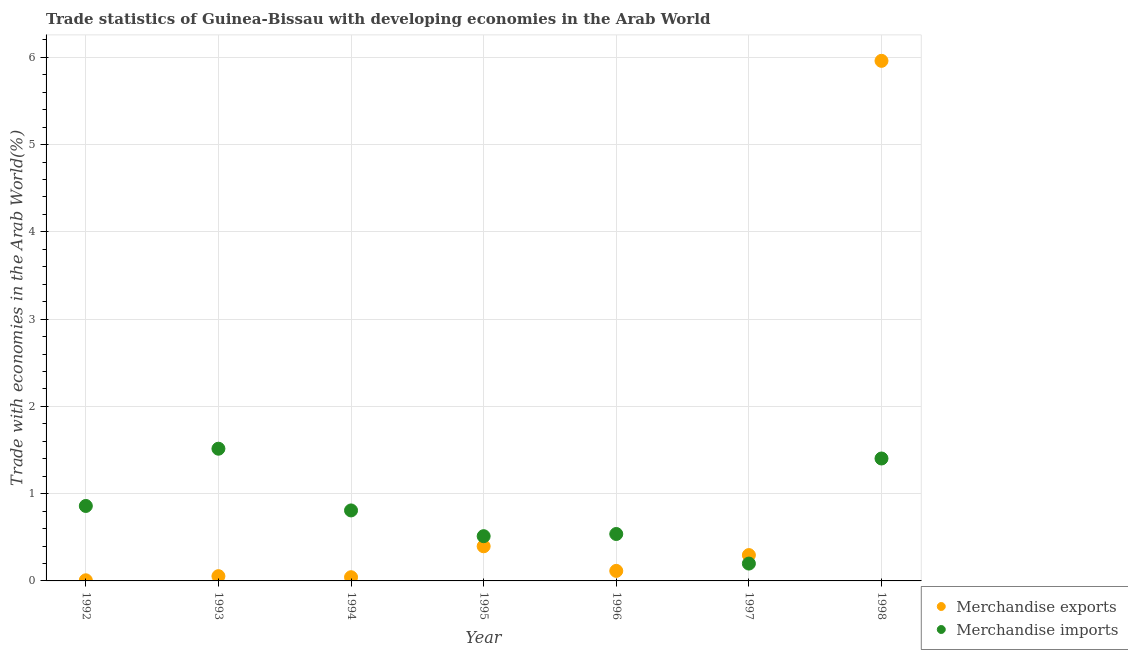What is the merchandise exports in 1994?
Your response must be concise. 0.04. Across all years, what is the maximum merchandise imports?
Give a very brief answer. 1.52. Across all years, what is the minimum merchandise imports?
Ensure brevity in your answer.  0.2. In which year was the merchandise exports maximum?
Your answer should be compact. 1998. What is the total merchandise imports in the graph?
Make the answer very short. 5.83. What is the difference between the merchandise exports in 1994 and that in 1997?
Your answer should be compact. -0.25. What is the difference between the merchandise exports in 1997 and the merchandise imports in 1998?
Give a very brief answer. -1.11. What is the average merchandise exports per year?
Make the answer very short. 0.98. In the year 1997, what is the difference between the merchandise exports and merchandise imports?
Your answer should be compact. 0.1. What is the ratio of the merchandise imports in 1992 to that in 1994?
Provide a short and direct response. 1.06. What is the difference between the highest and the second highest merchandise imports?
Keep it short and to the point. 0.11. What is the difference between the highest and the lowest merchandise imports?
Provide a succinct answer. 1.32. In how many years, is the merchandise exports greater than the average merchandise exports taken over all years?
Your answer should be very brief. 1. How many dotlines are there?
Provide a short and direct response. 2. Does the graph contain grids?
Offer a terse response. Yes. How many legend labels are there?
Offer a very short reply. 2. What is the title of the graph?
Give a very brief answer. Trade statistics of Guinea-Bissau with developing economies in the Arab World. Does "Mobile cellular" appear as one of the legend labels in the graph?
Provide a succinct answer. No. What is the label or title of the X-axis?
Your response must be concise. Year. What is the label or title of the Y-axis?
Provide a short and direct response. Trade with economies in the Arab World(%). What is the Trade with economies in the Arab World(%) in Merchandise exports in 1992?
Give a very brief answer. 0.01. What is the Trade with economies in the Arab World(%) in Merchandise imports in 1992?
Provide a short and direct response. 0.86. What is the Trade with economies in the Arab World(%) in Merchandise exports in 1993?
Ensure brevity in your answer.  0.05. What is the Trade with economies in the Arab World(%) of Merchandise imports in 1993?
Provide a succinct answer. 1.52. What is the Trade with economies in the Arab World(%) in Merchandise exports in 1994?
Your response must be concise. 0.04. What is the Trade with economies in the Arab World(%) of Merchandise imports in 1994?
Give a very brief answer. 0.81. What is the Trade with economies in the Arab World(%) of Merchandise exports in 1995?
Give a very brief answer. 0.4. What is the Trade with economies in the Arab World(%) of Merchandise imports in 1995?
Your answer should be very brief. 0.51. What is the Trade with economies in the Arab World(%) of Merchandise exports in 1996?
Make the answer very short. 0.11. What is the Trade with economies in the Arab World(%) of Merchandise imports in 1996?
Your response must be concise. 0.54. What is the Trade with economies in the Arab World(%) in Merchandise exports in 1997?
Your answer should be very brief. 0.3. What is the Trade with economies in the Arab World(%) in Merchandise imports in 1997?
Ensure brevity in your answer.  0.2. What is the Trade with economies in the Arab World(%) in Merchandise exports in 1998?
Your answer should be compact. 5.96. What is the Trade with economies in the Arab World(%) in Merchandise imports in 1998?
Offer a very short reply. 1.4. Across all years, what is the maximum Trade with economies in the Arab World(%) of Merchandise exports?
Keep it short and to the point. 5.96. Across all years, what is the maximum Trade with economies in the Arab World(%) of Merchandise imports?
Provide a short and direct response. 1.52. Across all years, what is the minimum Trade with economies in the Arab World(%) in Merchandise exports?
Your response must be concise. 0.01. Across all years, what is the minimum Trade with economies in the Arab World(%) of Merchandise imports?
Ensure brevity in your answer.  0.2. What is the total Trade with economies in the Arab World(%) of Merchandise exports in the graph?
Offer a terse response. 6.87. What is the total Trade with economies in the Arab World(%) in Merchandise imports in the graph?
Offer a very short reply. 5.83. What is the difference between the Trade with economies in the Arab World(%) in Merchandise exports in 1992 and that in 1993?
Your answer should be compact. -0.05. What is the difference between the Trade with economies in the Arab World(%) of Merchandise imports in 1992 and that in 1993?
Offer a terse response. -0.66. What is the difference between the Trade with economies in the Arab World(%) in Merchandise exports in 1992 and that in 1994?
Your response must be concise. -0.04. What is the difference between the Trade with economies in the Arab World(%) of Merchandise imports in 1992 and that in 1994?
Keep it short and to the point. 0.05. What is the difference between the Trade with economies in the Arab World(%) of Merchandise exports in 1992 and that in 1995?
Ensure brevity in your answer.  -0.39. What is the difference between the Trade with economies in the Arab World(%) of Merchandise imports in 1992 and that in 1995?
Provide a short and direct response. 0.35. What is the difference between the Trade with economies in the Arab World(%) in Merchandise exports in 1992 and that in 1996?
Your answer should be very brief. -0.11. What is the difference between the Trade with economies in the Arab World(%) in Merchandise imports in 1992 and that in 1996?
Make the answer very short. 0.32. What is the difference between the Trade with economies in the Arab World(%) in Merchandise exports in 1992 and that in 1997?
Your answer should be very brief. -0.29. What is the difference between the Trade with economies in the Arab World(%) of Merchandise imports in 1992 and that in 1997?
Ensure brevity in your answer.  0.66. What is the difference between the Trade with economies in the Arab World(%) of Merchandise exports in 1992 and that in 1998?
Offer a very short reply. -5.95. What is the difference between the Trade with economies in the Arab World(%) in Merchandise imports in 1992 and that in 1998?
Your response must be concise. -0.54. What is the difference between the Trade with economies in the Arab World(%) of Merchandise exports in 1993 and that in 1994?
Offer a very short reply. 0.01. What is the difference between the Trade with economies in the Arab World(%) in Merchandise imports in 1993 and that in 1994?
Provide a succinct answer. 0.71. What is the difference between the Trade with economies in the Arab World(%) in Merchandise exports in 1993 and that in 1995?
Your answer should be compact. -0.34. What is the difference between the Trade with economies in the Arab World(%) of Merchandise imports in 1993 and that in 1995?
Make the answer very short. 1. What is the difference between the Trade with economies in the Arab World(%) in Merchandise exports in 1993 and that in 1996?
Offer a very short reply. -0.06. What is the difference between the Trade with economies in the Arab World(%) in Merchandise imports in 1993 and that in 1996?
Your answer should be very brief. 0.98. What is the difference between the Trade with economies in the Arab World(%) in Merchandise exports in 1993 and that in 1997?
Offer a very short reply. -0.24. What is the difference between the Trade with economies in the Arab World(%) of Merchandise imports in 1993 and that in 1997?
Ensure brevity in your answer.  1.32. What is the difference between the Trade with economies in the Arab World(%) in Merchandise exports in 1993 and that in 1998?
Keep it short and to the point. -5.91. What is the difference between the Trade with economies in the Arab World(%) of Merchandise imports in 1993 and that in 1998?
Provide a succinct answer. 0.11. What is the difference between the Trade with economies in the Arab World(%) of Merchandise exports in 1994 and that in 1995?
Ensure brevity in your answer.  -0.35. What is the difference between the Trade with economies in the Arab World(%) of Merchandise imports in 1994 and that in 1995?
Give a very brief answer. 0.3. What is the difference between the Trade with economies in the Arab World(%) of Merchandise exports in 1994 and that in 1996?
Provide a short and direct response. -0.07. What is the difference between the Trade with economies in the Arab World(%) in Merchandise imports in 1994 and that in 1996?
Keep it short and to the point. 0.27. What is the difference between the Trade with economies in the Arab World(%) in Merchandise exports in 1994 and that in 1997?
Offer a very short reply. -0.25. What is the difference between the Trade with economies in the Arab World(%) in Merchandise imports in 1994 and that in 1997?
Offer a very short reply. 0.61. What is the difference between the Trade with economies in the Arab World(%) of Merchandise exports in 1994 and that in 1998?
Ensure brevity in your answer.  -5.92. What is the difference between the Trade with economies in the Arab World(%) in Merchandise imports in 1994 and that in 1998?
Keep it short and to the point. -0.6. What is the difference between the Trade with economies in the Arab World(%) of Merchandise exports in 1995 and that in 1996?
Offer a very short reply. 0.28. What is the difference between the Trade with economies in the Arab World(%) of Merchandise imports in 1995 and that in 1996?
Make the answer very short. -0.03. What is the difference between the Trade with economies in the Arab World(%) in Merchandise exports in 1995 and that in 1997?
Keep it short and to the point. 0.1. What is the difference between the Trade with economies in the Arab World(%) of Merchandise imports in 1995 and that in 1997?
Ensure brevity in your answer.  0.31. What is the difference between the Trade with economies in the Arab World(%) of Merchandise exports in 1995 and that in 1998?
Provide a short and direct response. -5.56. What is the difference between the Trade with economies in the Arab World(%) of Merchandise imports in 1995 and that in 1998?
Give a very brief answer. -0.89. What is the difference between the Trade with economies in the Arab World(%) in Merchandise exports in 1996 and that in 1997?
Make the answer very short. -0.18. What is the difference between the Trade with economies in the Arab World(%) of Merchandise imports in 1996 and that in 1997?
Your response must be concise. 0.34. What is the difference between the Trade with economies in the Arab World(%) in Merchandise exports in 1996 and that in 1998?
Your answer should be very brief. -5.84. What is the difference between the Trade with economies in the Arab World(%) of Merchandise imports in 1996 and that in 1998?
Make the answer very short. -0.87. What is the difference between the Trade with economies in the Arab World(%) in Merchandise exports in 1997 and that in 1998?
Provide a short and direct response. -5.66. What is the difference between the Trade with economies in the Arab World(%) of Merchandise imports in 1997 and that in 1998?
Ensure brevity in your answer.  -1.2. What is the difference between the Trade with economies in the Arab World(%) in Merchandise exports in 1992 and the Trade with economies in the Arab World(%) in Merchandise imports in 1993?
Keep it short and to the point. -1.51. What is the difference between the Trade with economies in the Arab World(%) in Merchandise exports in 1992 and the Trade with economies in the Arab World(%) in Merchandise imports in 1994?
Your answer should be very brief. -0.8. What is the difference between the Trade with economies in the Arab World(%) of Merchandise exports in 1992 and the Trade with economies in the Arab World(%) of Merchandise imports in 1995?
Your answer should be very brief. -0.51. What is the difference between the Trade with economies in the Arab World(%) of Merchandise exports in 1992 and the Trade with economies in the Arab World(%) of Merchandise imports in 1996?
Provide a succinct answer. -0.53. What is the difference between the Trade with economies in the Arab World(%) of Merchandise exports in 1992 and the Trade with economies in the Arab World(%) of Merchandise imports in 1997?
Your response must be concise. -0.19. What is the difference between the Trade with economies in the Arab World(%) of Merchandise exports in 1992 and the Trade with economies in the Arab World(%) of Merchandise imports in 1998?
Offer a very short reply. -1.4. What is the difference between the Trade with economies in the Arab World(%) in Merchandise exports in 1993 and the Trade with economies in the Arab World(%) in Merchandise imports in 1994?
Keep it short and to the point. -0.75. What is the difference between the Trade with economies in the Arab World(%) of Merchandise exports in 1993 and the Trade with economies in the Arab World(%) of Merchandise imports in 1995?
Your answer should be very brief. -0.46. What is the difference between the Trade with economies in the Arab World(%) of Merchandise exports in 1993 and the Trade with economies in the Arab World(%) of Merchandise imports in 1996?
Offer a very short reply. -0.48. What is the difference between the Trade with economies in the Arab World(%) in Merchandise exports in 1993 and the Trade with economies in the Arab World(%) in Merchandise imports in 1997?
Your response must be concise. -0.14. What is the difference between the Trade with economies in the Arab World(%) of Merchandise exports in 1993 and the Trade with economies in the Arab World(%) of Merchandise imports in 1998?
Offer a terse response. -1.35. What is the difference between the Trade with economies in the Arab World(%) of Merchandise exports in 1994 and the Trade with economies in the Arab World(%) of Merchandise imports in 1995?
Offer a very short reply. -0.47. What is the difference between the Trade with economies in the Arab World(%) in Merchandise exports in 1994 and the Trade with economies in the Arab World(%) in Merchandise imports in 1996?
Provide a succinct answer. -0.5. What is the difference between the Trade with economies in the Arab World(%) in Merchandise exports in 1994 and the Trade with economies in the Arab World(%) in Merchandise imports in 1997?
Offer a very short reply. -0.16. What is the difference between the Trade with economies in the Arab World(%) of Merchandise exports in 1994 and the Trade with economies in the Arab World(%) of Merchandise imports in 1998?
Your answer should be very brief. -1.36. What is the difference between the Trade with economies in the Arab World(%) of Merchandise exports in 1995 and the Trade with economies in the Arab World(%) of Merchandise imports in 1996?
Ensure brevity in your answer.  -0.14. What is the difference between the Trade with economies in the Arab World(%) of Merchandise exports in 1995 and the Trade with economies in the Arab World(%) of Merchandise imports in 1997?
Give a very brief answer. 0.2. What is the difference between the Trade with economies in the Arab World(%) in Merchandise exports in 1995 and the Trade with economies in the Arab World(%) in Merchandise imports in 1998?
Your answer should be compact. -1.01. What is the difference between the Trade with economies in the Arab World(%) of Merchandise exports in 1996 and the Trade with economies in the Arab World(%) of Merchandise imports in 1997?
Offer a very short reply. -0.08. What is the difference between the Trade with economies in the Arab World(%) of Merchandise exports in 1996 and the Trade with economies in the Arab World(%) of Merchandise imports in 1998?
Your response must be concise. -1.29. What is the difference between the Trade with economies in the Arab World(%) in Merchandise exports in 1997 and the Trade with economies in the Arab World(%) in Merchandise imports in 1998?
Give a very brief answer. -1.11. What is the average Trade with economies in the Arab World(%) in Merchandise exports per year?
Offer a very short reply. 0.98. What is the average Trade with economies in the Arab World(%) in Merchandise imports per year?
Provide a short and direct response. 0.83. In the year 1992, what is the difference between the Trade with economies in the Arab World(%) in Merchandise exports and Trade with economies in the Arab World(%) in Merchandise imports?
Give a very brief answer. -0.85. In the year 1993, what is the difference between the Trade with economies in the Arab World(%) in Merchandise exports and Trade with economies in the Arab World(%) in Merchandise imports?
Your response must be concise. -1.46. In the year 1994, what is the difference between the Trade with economies in the Arab World(%) of Merchandise exports and Trade with economies in the Arab World(%) of Merchandise imports?
Offer a terse response. -0.77. In the year 1995, what is the difference between the Trade with economies in the Arab World(%) in Merchandise exports and Trade with economies in the Arab World(%) in Merchandise imports?
Offer a terse response. -0.12. In the year 1996, what is the difference between the Trade with economies in the Arab World(%) of Merchandise exports and Trade with economies in the Arab World(%) of Merchandise imports?
Give a very brief answer. -0.42. In the year 1997, what is the difference between the Trade with economies in the Arab World(%) of Merchandise exports and Trade with economies in the Arab World(%) of Merchandise imports?
Make the answer very short. 0.1. In the year 1998, what is the difference between the Trade with economies in the Arab World(%) of Merchandise exports and Trade with economies in the Arab World(%) of Merchandise imports?
Your answer should be compact. 4.56. What is the ratio of the Trade with economies in the Arab World(%) in Merchandise exports in 1992 to that in 1993?
Give a very brief answer. 0.13. What is the ratio of the Trade with economies in the Arab World(%) of Merchandise imports in 1992 to that in 1993?
Your answer should be compact. 0.57. What is the ratio of the Trade with economies in the Arab World(%) of Merchandise exports in 1992 to that in 1994?
Your response must be concise. 0.17. What is the ratio of the Trade with economies in the Arab World(%) in Merchandise imports in 1992 to that in 1994?
Ensure brevity in your answer.  1.06. What is the ratio of the Trade with economies in the Arab World(%) in Merchandise exports in 1992 to that in 1995?
Provide a short and direct response. 0.02. What is the ratio of the Trade with economies in the Arab World(%) of Merchandise imports in 1992 to that in 1995?
Provide a short and direct response. 1.68. What is the ratio of the Trade with economies in the Arab World(%) in Merchandise exports in 1992 to that in 1996?
Your answer should be compact. 0.06. What is the ratio of the Trade with economies in the Arab World(%) in Merchandise imports in 1992 to that in 1996?
Your answer should be very brief. 1.6. What is the ratio of the Trade with economies in the Arab World(%) in Merchandise exports in 1992 to that in 1997?
Your response must be concise. 0.02. What is the ratio of the Trade with economies in the Arab World(%) of Merchandise imports in 1992 to that in 1997?
Provide a succinct answer. 4.32. What is the ratio of the Trade with economies in the Arab World(%) in Merchandise exports in 1992 to that in 1998?
Your answer should be compact. 0. What is the ratio of the Trade with economies in the Arab World(%) of Merchandise imports in 1992 to that in 1998?
Give a very brief answer. 0.61. What is the ratio of the Trade with economies in the Arab World(%) of Merchandise exports in 1993 to that in 1994?
Your answer should be very brief. 1.28. What is the ratio of the Trade with economies in the Arab World(%) of Merchandise imports in 1993 to that in 1994?
Your response must be concise. 1.88. What is the ratio of the Trade with economies in the Arab World(%) in Merchandise exports in 1993 to that in 1995?
Provide a succinct answer. 0.14. What is the ratio of the Trade with economies in the Arab World(%) in Merchandise imports in 1993 to that in 1995?
Provide a short and direct response. 2.96. What is the ratio of the Trade with economies in the Arab World(%) of Merchandise exports in 1993 to that in 1996?
Your answer should be compact. 0.47. What is the ratio of the Trade with economies in the Arab World(%) in Merchandise imports in 1993 to that in 1996?
Ensure brevity in your answer.  2.82. What is the ratio of the Trade with economies in the Arab World(%) in Merchandise exports in 1993 to that in 1997?
Offer a very short reply. 0.18. What is the ratio of the Trade with economies in the Arab World(%) in Merchandise imports in 1993 to that in 1997?
Give a very brief answer. 7.62. What is the ratio of the Trade with economies in the Arab World(%) in Merchandise exports in 1993 to that in 1998?
Provide a succinct answer. 0.01. What is the ratio of the Trade with economies in the Arab World(%) of Merchandise imports in 1993 to that in 1998?
Ensure brevity in your answer.  1.08. What is the ratio of the Trade with economies in the Arab World(%) of Merchandise exports in 1994 to that in 1995?
Offer a terse response. 0.11. What is the ratio of the Trade with economies in the Arab World(%) of Merchandise imports in 1994 to that in 1995?
Provide a succinct answer. 1.58. What is the ratio of the Trade with economies in the Arab World(%) in Merchandise exports in 1994 to that in 1996?
Provide a short and direct response. 0.37. What is the ratio of the Trade with economies in the Arab World(%) in Merchandise imports in 1994 to that in 1996?
Keep it short and to the point. 1.5. What is the ratio of the Trade with economies in the Arab World(%) of Merchandise exports in 1994 to that in 1997?
Your response must be concise. 0.14. What is the ratio of the Trade with economies in the Arab World(%) of Merchandise imports in 1994 to that in 1997?
Provide a succinct answer. 4.06. What is the ratio of the Trade with economies in the Arab World(%) in Merchandise exports in 1994 to that in 1998?
Your response must be concise. 0.01. What is the ratio of the Trade with economies in the Arab World(%) in Merchandise imports in 1994 to that in 1998?
Keep it short and to the point. 0.58. What is the ratio of the Trade with economies in the Arab World(%) of Merchandise exports in 1995 to that in 1996?
Keep it short and to the point. 3.45. What is the ratio of the Trade with economies in the Arab World(%) of Merchandise imports in 1995 to that in 1996?
Make the answer very short. 0.95. What is the ratio of the Trade with economies in the Arab World(%) in Merchandise exports in 1995 to that in 1997?
Provide a short and direct response. 1.34. What is the ratio of the Trade with economies in the Arab World(%) in Merchandise imports in 1995 to that in 1997?
Offer a very short reply. 2.58. What is the ratio of the Trade with economies in the Arab World(%) in Merchandise exports in 1995 to that in 1998?
Your answer should be very brief. 0.07. What is the ratio of the Trade with economies in the Arab World(%) of Merchandise imports in 1995 to that in 1998?
Give a very brief answer. 0.37. What is the ratio of the Trade with economies in the Arab World(%) of Merchandise exports in 1996 to that in 1997?
Your answer should be very brief. 0.39. What is the ratio of the Trade with economies in the Arab World(%) in Merchandise imports in 1996 to that in 1997?
Offer a very short reply. 2.71. What is the ratio of the Trade with economies in the Arab World(%) in Merchandise exports in 1996 to that in 1998?
Make the answer very short. 0.02. What is the ratio of the Trade with economies in the Arab World(%) of Merchandise imports in 1996 to that in 1998?
Ensure brevity in your answer.  0.38. What is the ratio of the Trade with economies in the Arab World(%) of Merchandise exports in 1997 to that in 1998?
Give a very brief answer. 0.05. What is the ratio of the Trade with economies in the Arab World(%) of Merchandise imports in 1997 to that in 1998?
Ensure brevity in your answer.  0.14. What is the difference between the highest and the second highest Trade with economies in the Arab World(%) in Merchandise exports?
Give a very brief answer. 5.56. What is the difference between the highest and the second highest Trade with economies in the Arab World(%) in Merchandise imports?
Offer a very short reply. 0.11. What is the difference between the highest and the lowest Trade with economies in the Arab World(%) of Merchandise exports?
Your answer should be very brief. 5.95. What is the difference between the highest and the lowest Trade with economies in the Arab World(%) of Merchandise imports?
Give a very brief answer. 1.32. 